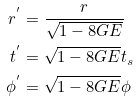<formula> <loc_0><loc_0><loc_500><loc_500>r ^ { ^ { \prime } } & = \frac { r } { \sqrt { 1 - 8 G E } } \\ t ^ { ^ { \prime } } & = \sqrt { 1 - 8 G E } t _ { s } \\ \phi ^ { ^ { \prime } } & = \sqrt { 1 - 8 G E } \phi</formula> 